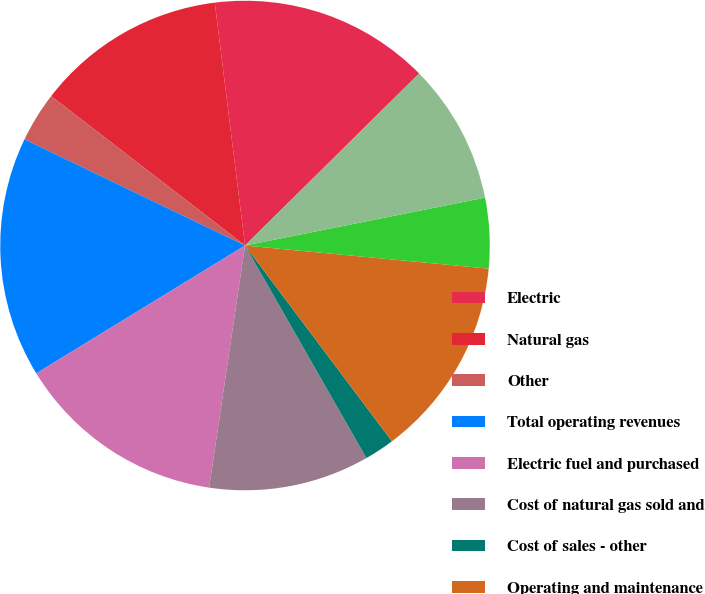Convert chart to OTSL. <chart><loc_0><loc_0><loc_500><loc_500><pie_chart><fcel>Electric<fcel>Natural gas<fcel>Other<fcel>Total operating revenues<fcel>Electric fuel and purchased<fcel>Cost of natural gas sold and<fcel>Cost of sales - other<fcel>Operating and maintenance<fcel>Conservation and demand side<fcel>Depreciation and amortization<nl><fcel>14.57%<fcel>12.58%<fcel>3.31%<fcel>15.89%<fcel>13.91%<fcel>10.6%<fcel>1.99%<fcel>13.25%<fcel>4.64%<fcel>9.27%<nl></chart> 